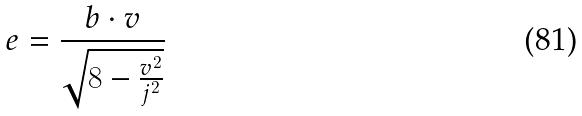<formula> <loc_0><loc_0><loc_500><loc_500>e = \frac { b \cdot v } { \sqrt { 8 - \frac { v ^ { 2 } } { j ^ { 2 } } } }</formula> 